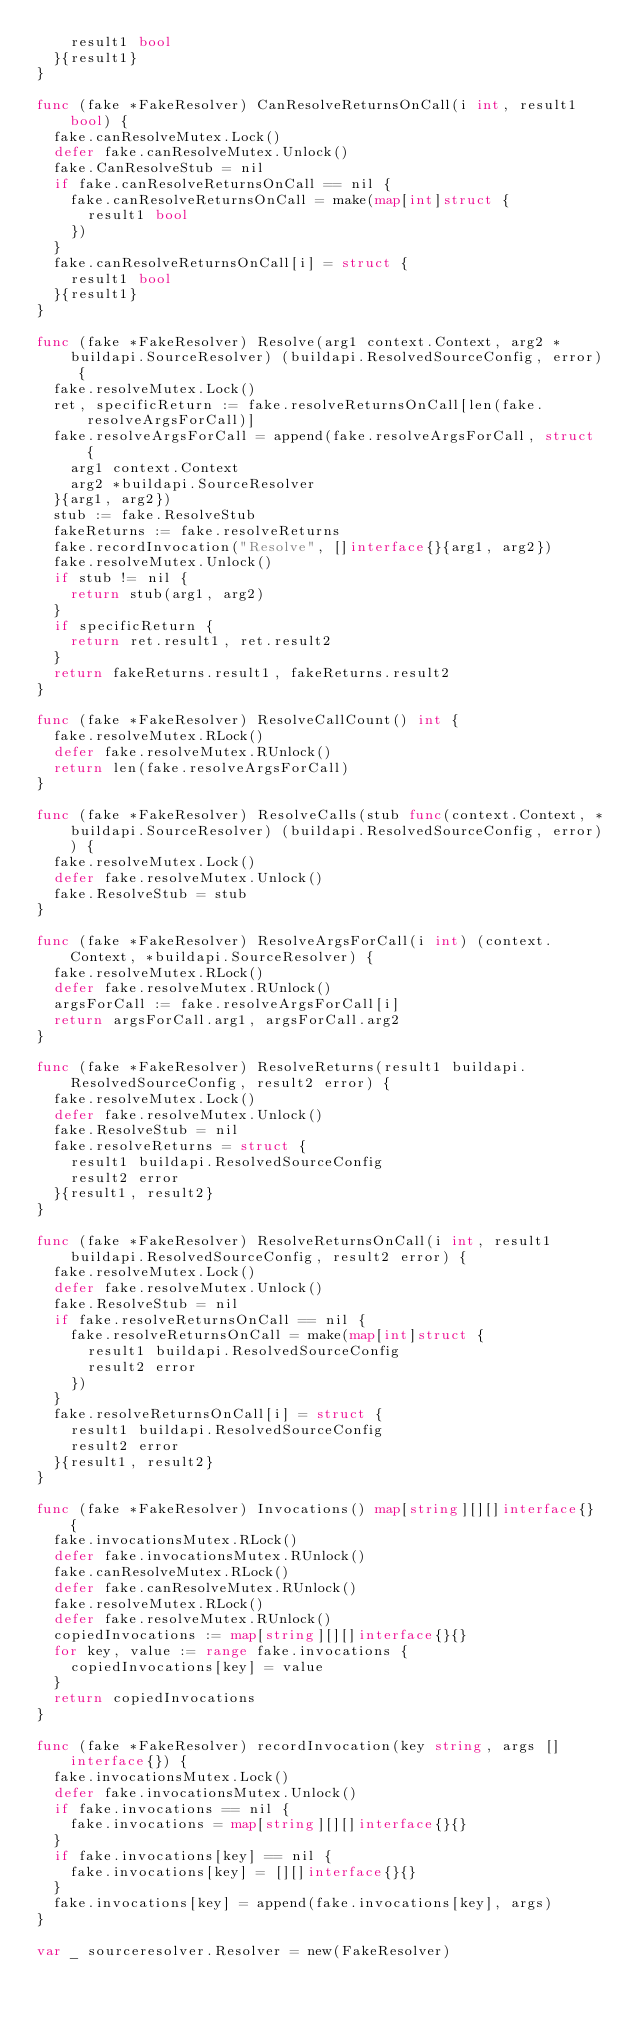Convert code to text. <code><loc_0><loc_0><loc_500><loc_500><_Go_>		result1 bool
	}{result1}
}

func (fake *FakeResolver) CanResolveReturnsOnCall(i int, result1 bool) {
	fake.canResolveMutex.Lock()
	defer fake.canResolveMutex.Unlock()
	fake.CanResolveStub = nil
	if fake.canResolveReturnsOnCall == nil {
		fake.canResolveReturnsOnCall = make(map[int]struct {
			result1 bool
		})
	}
	fake.canResolveReturnsOnCall[i] = struct {
		result1 bool
	}{result1}
}

func (fake *FakeResolver) Resolve(arg1 context.Context, arg2 *buildapi.SourceResolver) (buildapi.ResolvedSourceConfig, error) {
	fake.resolveMutex.Lock()
	ret, specificReturn := fake.resolveReturnsOnCall[len(fake.resolveArgsForCall)]
	fake.resolveArgsForCall = append(fake.resolveArgsForCall, struct {
		arg1 context.Context
		arg2 *buildapi.SourceResolver
	}{arg1, arg2})
	stub := fake.ResolveStub
	fakeReturns := fake.resolveReturns
	fake.recordInvocation("Resolve", []interface{}{arg1, arg2})
	fake.resolveMutex.Unlock()
	if stub != nil {
		return stub(arg1, arg2)
	}
	if specificReturn {
		return ret.result1, ret.result2
	}
	return fakeReturns.result1, fakeReturns.result2
}

func (fake *FakeResolver) ResolveCallCount() int {
	fake.resolveMutex.RLock()
	defer fake.resolveMutex.RUnlock()
	return len(fake.resolveArgsForCall)
}

func (fake *FakeResolver) ResolveCalls(stub func(context.Context, *buildapi.SourceResolver) (buildapi.ResolvedSourceConfig, error)) {
	fake.resolveMutex.Lock()
	defer fake.resolveMutex.Unlock()
	fake.ResolveStub = stub
}

func (fake *FakeResolver) ResolveArgsForCall(i int) (context.Context, *buildapi.SourceResolver) {
	fake.resolveMutex.RLock()
	defer fake.resolveMutex.RUnlock()
	argsForCall := fake.resolveArgsForCall[i]
	return argsForCall.arg1, argsForCall.arg2
}

func (fake *FakeResolver) ResolveReturns(result1 buildapi.ResolvedSourceConfig, result2 error) {
	fake.resolveMutex.Lock()
	defer fake.resolveMutex.Unlock()
	fake.ResolveStub = nil
	fake.resolveReturns = struct {
		result1 buildapi.ResolvedSourceConfig
		result2 error
	}{result1, result2}
}

func (fake *FakeResolver) ResolveReturnsOnCall(i int, result1 buildapi.ResolvedSourceConfig, result2 error) {
	fake.resolveMutex.Lock()
	defer fake.resolveMutex.Unlock()
	fake.ResolveStub = nil
	if fake.resolveReturnsOnCall == nil {
		fake.resolveReturnsOnCall = make(map[int]struct {
			result1 buildapi.ResolvedSourceConfig
			result2 error
		})
	}
	fake.resolveReturnsOnCall[i] = struct {
		result1 buildapi.ResolvedSourceConfig
		result2 error
	}{result1, result2}
}

func (fake *FakeResolver) Invocations() map[string][][]interface{} {
	fake.invocationsMutex.RLock()
	defer fake.invocationsMutex.RUnlock()
	fake.canResolveMutex.RLock()
	defer fake.canResolveMutex.RUnlock()
	fake.resolveMutex.RLock()
	defer fake.resolveMutex.RUnlock()
	copiedInvocations := map[string][][]interface{}{}
	for key, value := range fake.invocations {
		copiedInvocations[key] = value
	}
	return copiedInvocations
}

func (fake *FakeResolver) recordInvocation(key string, args []interface{}) {
	fake.invocationsMutex.Lock()
	defer fake.invocationsMutex.Unlock()
	if fake.invocations == nil {
		fake.invocations = map[string][][]interface{}{}
	}
	if fake.invocations[key] == nil {
		fake.invocations[key] = [][]interface{}{}
	}
	fake.invocations[key] = append(fake.invocations[key], args)
}

var _ sourceresolver.Resolver = new(FakeResolver)
</code> 